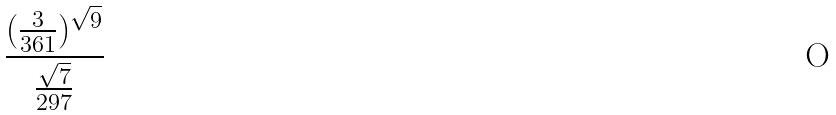<formula> <loc_0><loc_0><loc_500><loc_500>\frac { ( \frac { 3 } { 3 6 1 } ) ^ { \sqrt { 9 } } } { \frac { \sqrt { 7 } } { 2 9 7 } }</formula> 